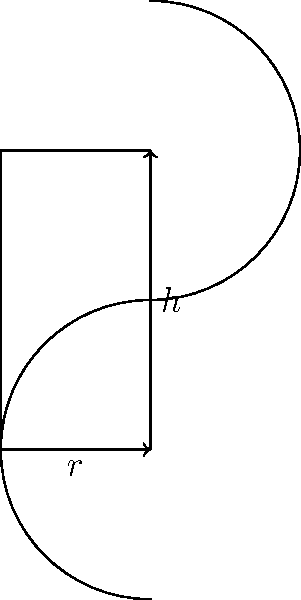As a chef specializing in kosher cuisine, you're designing a cylindrical container to store kosher-certified meat products. The container must have a surface area of 400 square inches (including top and bottom). What dimensions (radius and height) will maximize the volume of the container? Let's approach this step-by-step:

1) Let $r$ be the radius and $h$ be the height of the cylinder.

2) The surface area of a cylinder is given by:
   $$ A = 2\pi r^2 + 2\pi rh $$

3) We're told that the surface area is 400 square inches, so:
   $$ 400 = 2\pi r^2 + 2\pi rh $$

4) Solving for $h$:
   $$ h = \frac{200}{\pi r} - r $$

5) The volume of a cylinder is given by:
   $$ V = \pi r^2h $$

6) Substituting our expression for $h$:
   $$ V = \pi r^2(\frac{200}{\pi r} - r) = 200r - \pi r^3 $$

7) To find the maximum volume, we differentiate $V$ with respect to $r$ and set it to zero:
   $$ \frac{dV}{dr} = 200 - 3\pi r^2 = 0 $$

8) Solving this equation:
   $$ 200 = 3\pi r^2 $$
   $$ r^2 = \frac{200}{3\pi} $$
   $$ r = \sqrt{\frac{200}{3\pi}} \approx 4.60 \text{ inches} $$

9) We can find $h$ by substituting this value of $r$ back into our equation from step 4:
   $$ h = \frac{200}{\pi r} - r \approx 9.20 \text{ inches} $$

10) To verify this is a maximum, we can check that the second derivative is negative at this point.

Therefore, the volume is maximized when the radius is approximately 4.60 inches and the height is approximately 9.20 inches.
Answer: $r \approx 4.60$ inches, $h \approx 9.20$ inches 